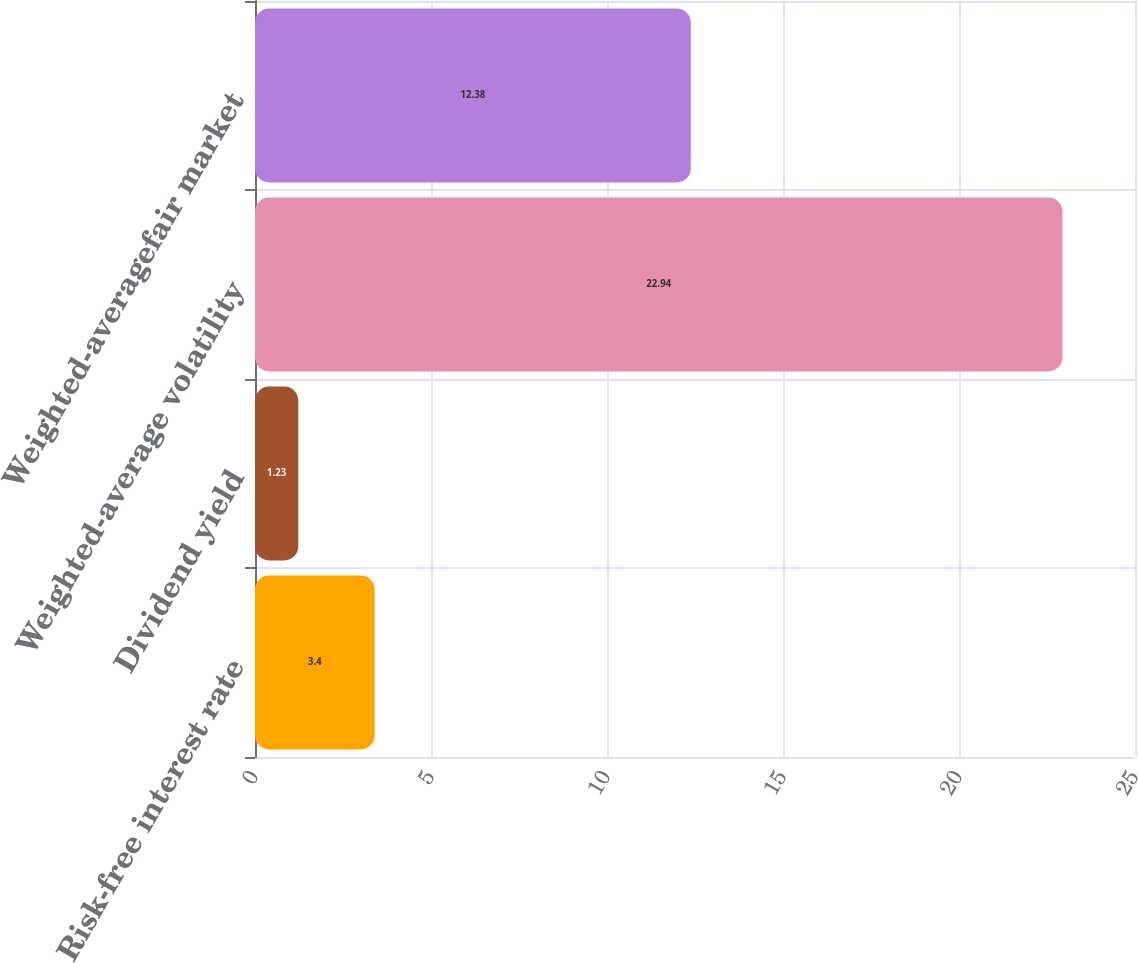<chart> <loc_0><loc_0><loc_500><loc_500><bar_chart><fcel>Risk-free interest rate<fcel>Dividend yield<fcel>Weighted-average volatility<fcel>Weighted-averagefair market<nl><fcel>3.4<fcel>1.23<fcel>22.94<fcel>12.38<nl></chart> 